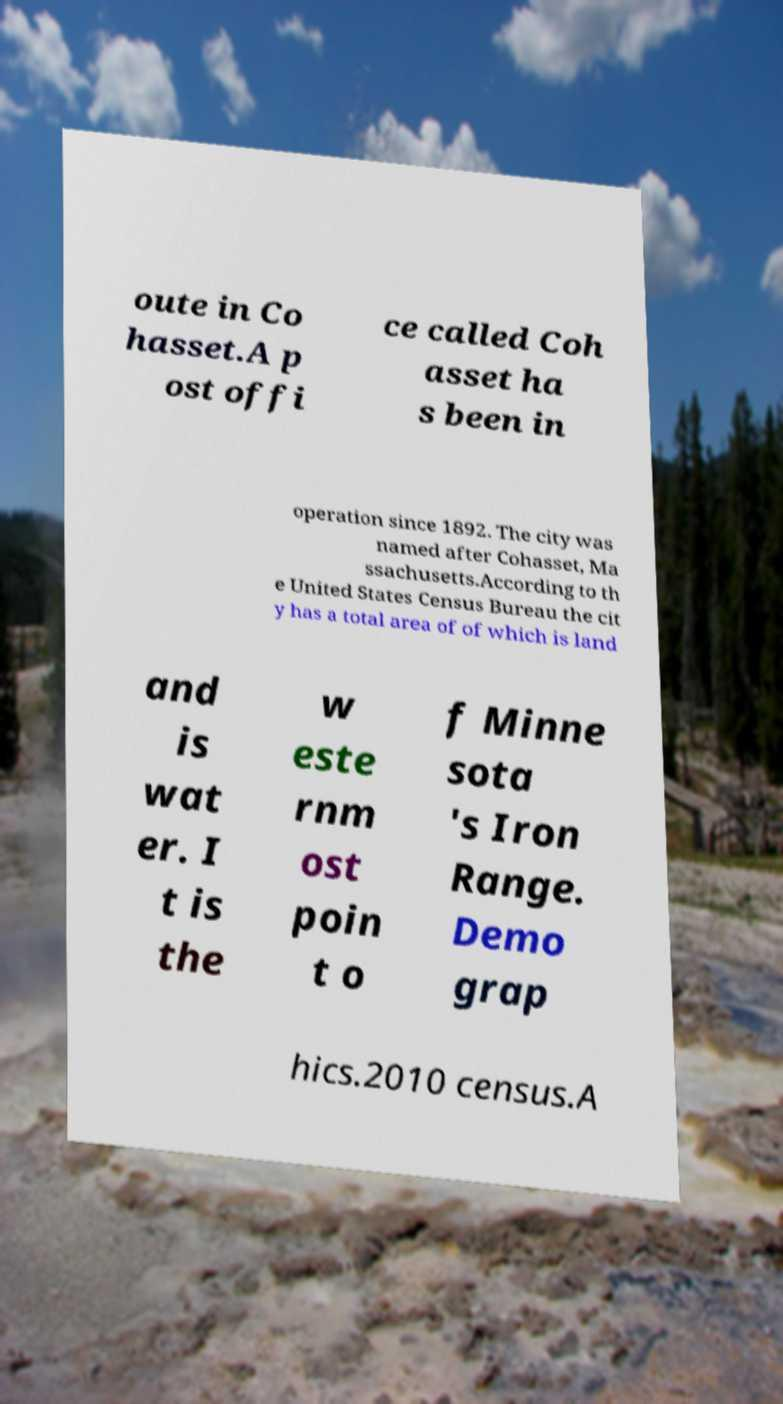Can you read and provide the text displayed in the image?This photo seems to have some interesting text. Can you extract and type it out for me? oute in Co hasset.A p ost offi ce called Coh asset ha s been in operation since 1892. The city was named after Cohasset, Ma ssachusetts.According to th e United States Census Bureau the cit y has a total area of of which is land and is wat er. I t is the w este rnm ost poin t o f Minne sota 's Iron Range. Demo grap hics.2010 census.A 